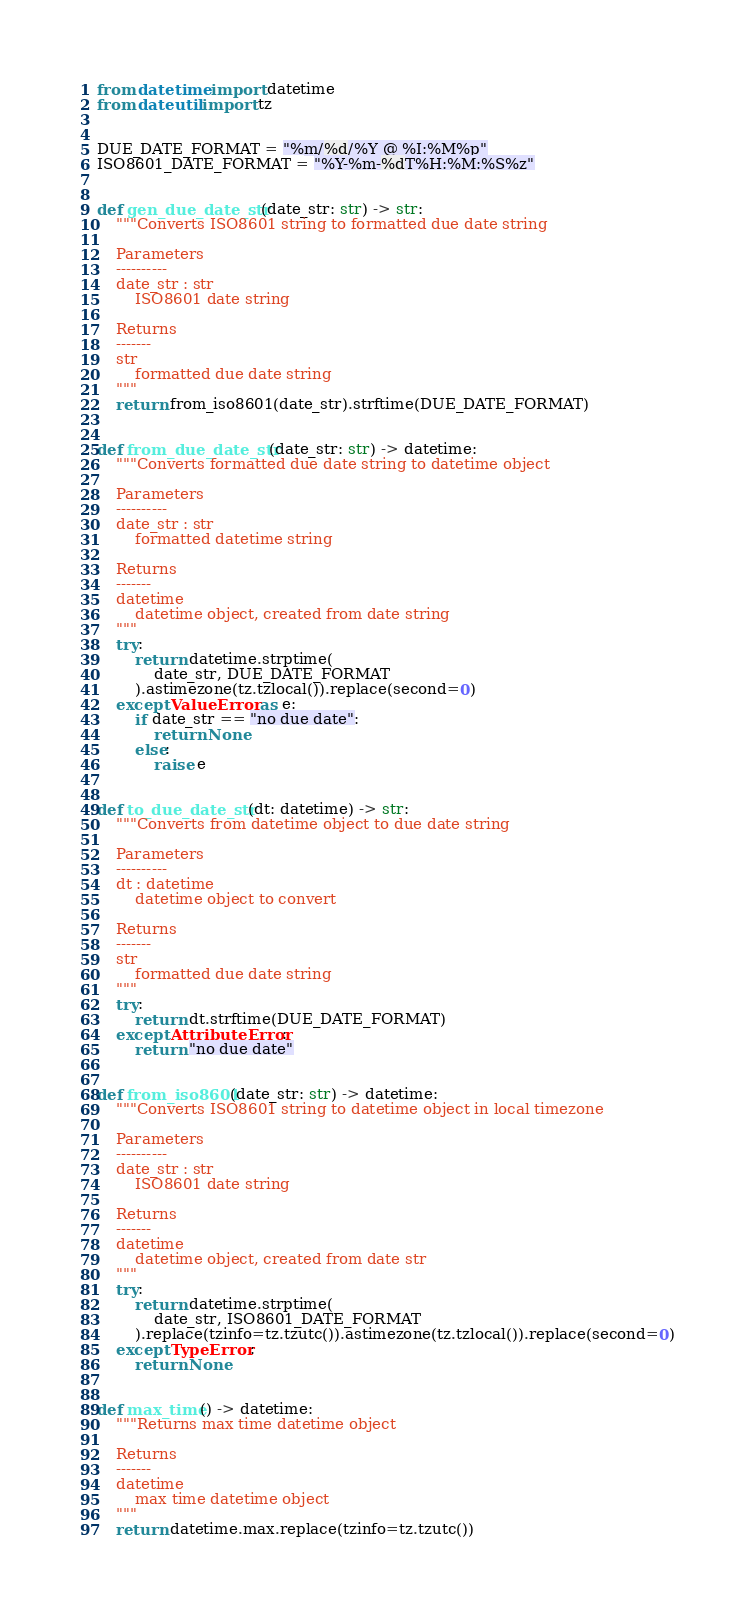<code> <loc_0><loc_0><loc_500><loc_500><_Python_>from datetime import datetime
from dateutil import tz


DUE_DATE_FORMAT = "%m/%d/%Y @ %I:%M%p"
ISO8601_DATE_FORMAT = "%Y-%m-%dT%H:%M:%S%z"


def gen_due_date_str(date_str: str) -> str:
    """Converts ISO8601 string to formatted due date string

    Parameters
    ----------
    date_str : str
        ISO8601 date string

    Returns
    -------
    str
        formatted due date string
    """
    return from_iso8601(date_str).strftime(DUE_DATE_FORMAT)


def from_due_date_str(date_str: str) -> datetime:
    """Converts formatted due date string to datetime object

    Parameters
    ----------
    date_str : str
        formatted datetime string

    Returns
    -------
    datetime
        datetime object, created from date string
    """
    try:
        return datetime.strptime(
            date_str, DUE_DATE_FORMAT
        ).astimezone(tz.tzlocal()).replace(second=0)
    except ValueError as e:
        if date_str == "no due date":
            return None
        else:
            raise e


def to_due_date_str(dt: datetime) -> str:
    """Converts from datetime object to due date string

    Parameters
    ----------
    dt : datetime
        datetime object to convert

    Returns
    -------
    str
        formatted due date string
    """
    try:
        return dt.strftime(DUE_DATE_FORMAT)
    except AttributeError:
        return "no due date"


def from_iso8601(date_str: str) -> datetime:
    """Converts ISO8601 string to datetime object in local timezone

    Parameters
    ----------
    date_str : str
        ISO8601 date string

    Returns
    -------
    datetime
        datetime object, created from date str
    """
    try:
        return datetime.strptime(
            date_str, ISO8601_DATE_FORMAT
        ).replace(tzinfo=tz.tzutc()).astimezone(tz.tzlocal()).replace(second=0)
    except TypeError:
        return None


def max_time() -> datetime:
    """Returns max time datetime object

    Returns
    -------
    datetime
        max time datetime object
    """
    return datetime.max.replace(tzinfo=tz.tzutc())
</code> 